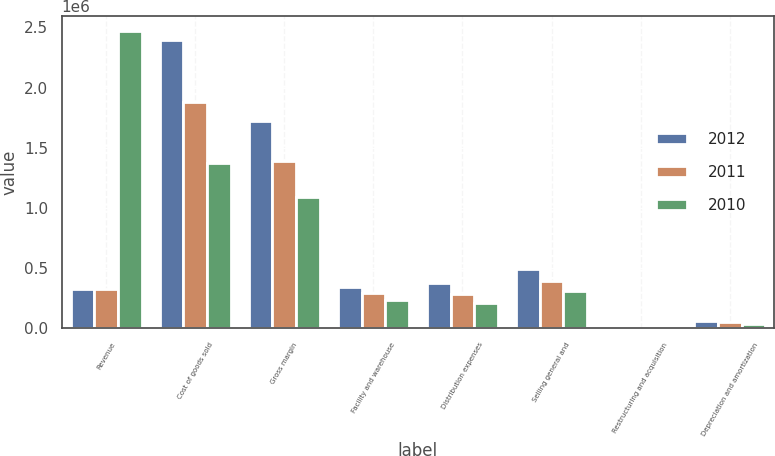<chart> <loc_0><loc_0><loc_500><loc_500><stacked_bar_chart><ecel><fcel>Revenue<fcel>Cost of goods sold<fcel>Gross margin<fcel>Facility and warehouse<fcel>Distribution expenses<fcel>Selling general and<fcel>Restructuring and acquisition<fcel>Depreciation and amortization<nl><fcel>2012<fcel>329072<fcel>2.39879e+06<fcel>1.72414e+06<fcel>347917<fcel>375835<fcel>495591<fcel>2751<fcel>64093<nl><fcel>2011<fcel>329072<fcel>1.87787e+06<fcel>1.39199e+06<fcel>293423<fcel>287626<fcel>391942<fcel>7590<fcel>49929<nl><fcel>2010<fcel>2.46988e+06<fcel>1.3764e+06<fcel>1.09348e+06<fcel>233993<fcel>212718<fcel>310228<fcel>668<fcel>37996<nl></chart> 